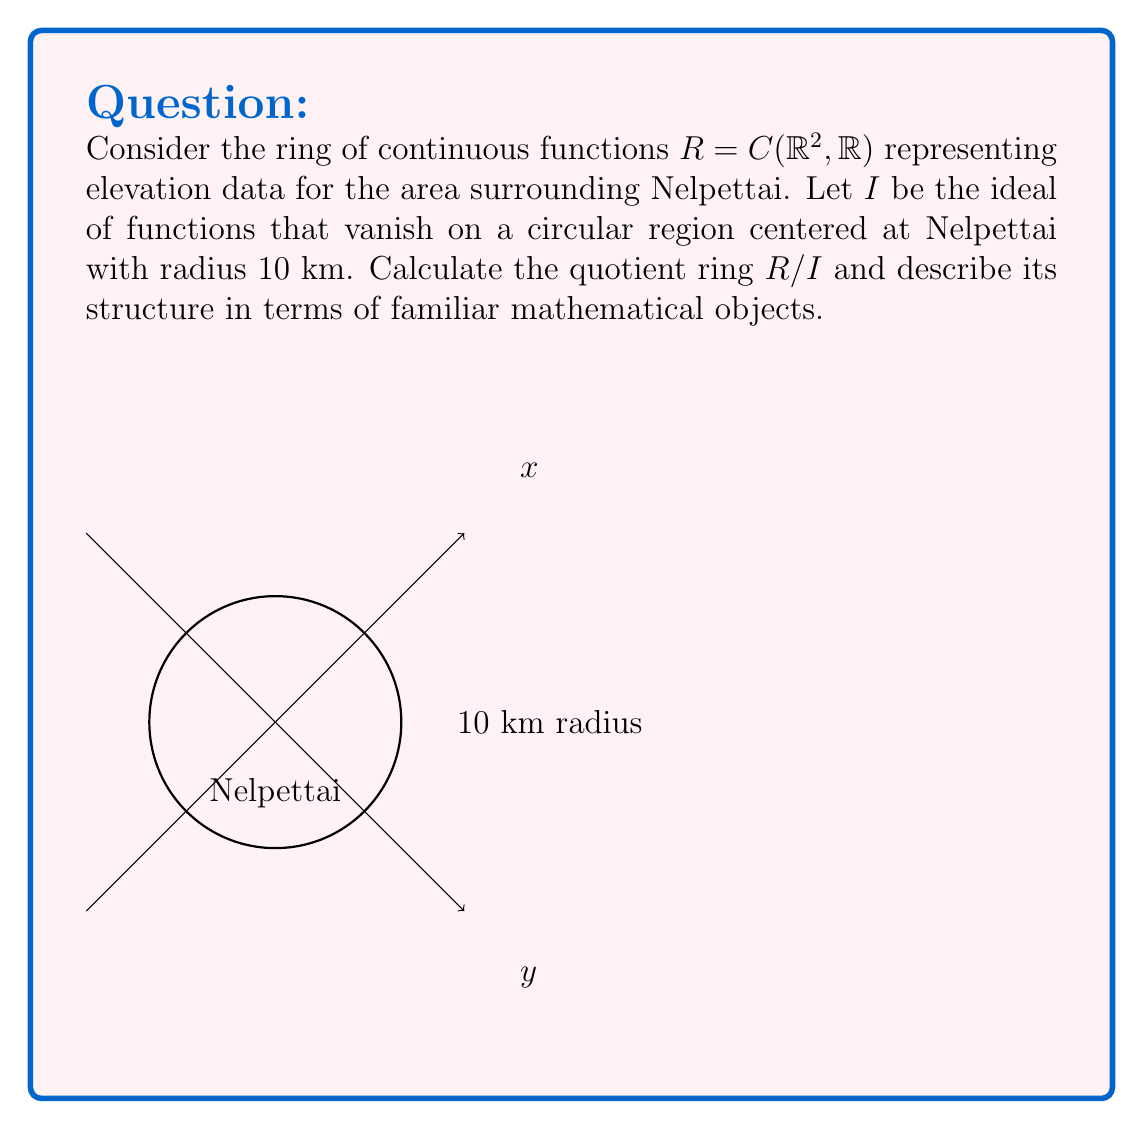Show me your answer to this math problem. Let's approach this step-by-step:

1) First, we need to understand what the quotient ring $R/I$ represents. It consists of equivalence classes of functions that agree on the circular region around Nelpettai.

2) The ideal $I$ contains all functions that are zero within the 10 km radius of Nelpettai. Two functions $f$ and $g$ are equivalent in $R/I$ if and only if $f - g \in I$, meaning they agree on the circular region.

3) By the First Isomorphism Theorem for rings, we know that $R/I$ is isomorphic to the image of the evaluation map $\phi: R \to C(D, \mathbb{R})$, where $D$ is the closed disk of radius 10 km centered at Nelpettai.

4) This map $\phi$ simply restricts each function in $R$ to the disk $D$. Its image is precisely $C(D, \mathbb{R})$, the ring of all continuous real-valued functions on $D$.

5) Therefore, we can conclude that $R/I \cong C(D, \mathbb{R})$.

6) The ring $C(D, \mathbb{R})$ is a well-known mathematical object. It's a commutative ring with unity, but not a field (as it contains zero divisors). It's also an infinite-dimensional real vector space.
Answer: $R/I \cong C(D, \mathbb{R})$, where $D$ is the closed disk of radius 10 km centered at Nelpettai. 